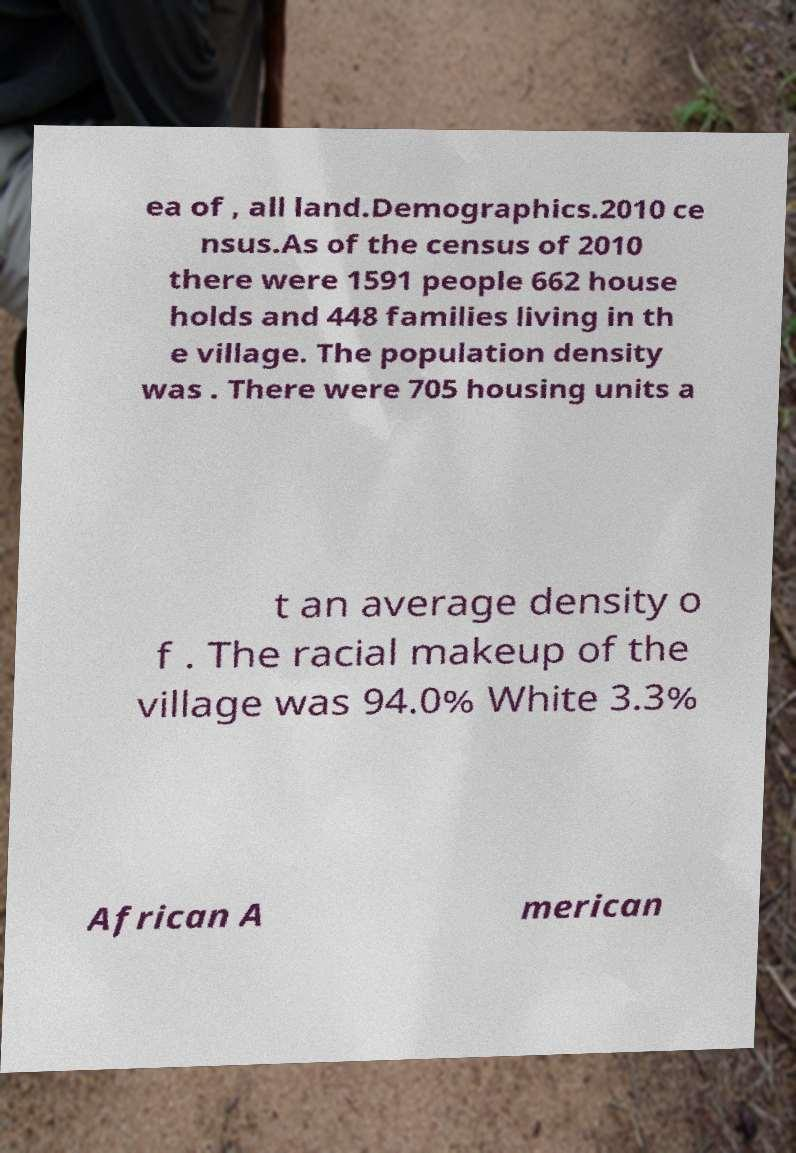Please read and relay the text visible in this image. What does it say? ea of , all land.Demographics.2010 ce nsus.As of the census of 2010 there were 1591 people 662 house holds and 448 families living in th e village. The population density was . There were 705 housing units a t an average density o f . The racial makeup of the village was 94.0% White 3.3% African A merican 